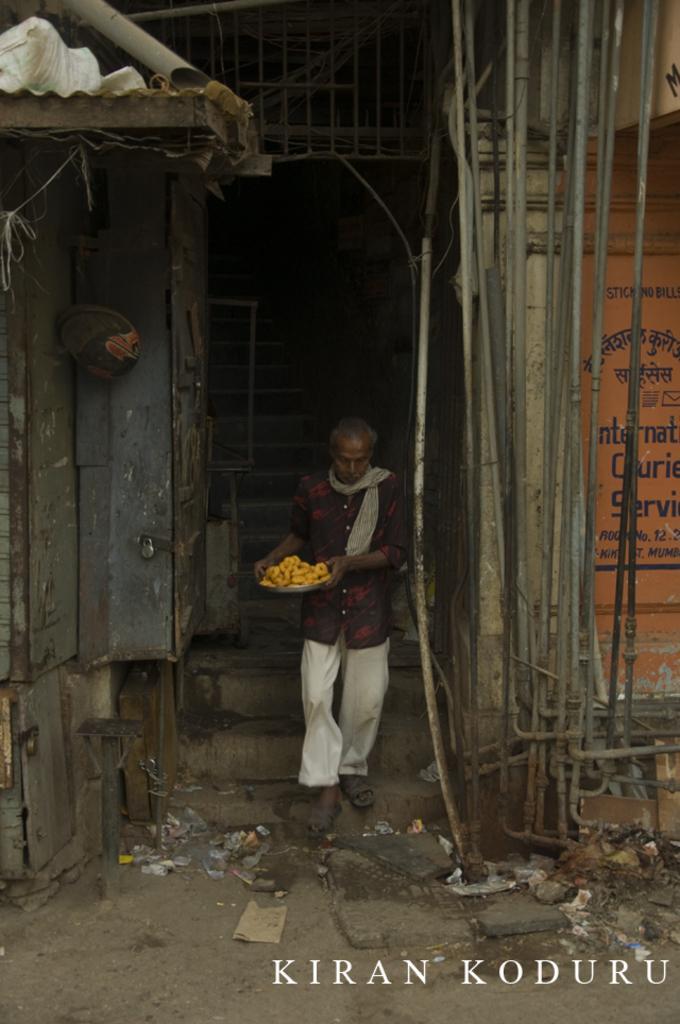How would you summarize this image in a sentence or two? In this picture we can see a man is holding a plate and walking on the path. Behind the man there are steps, wall, pipes and other things. On the image there is a watermark. 